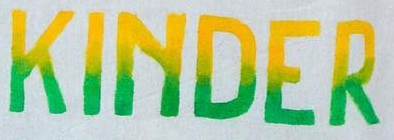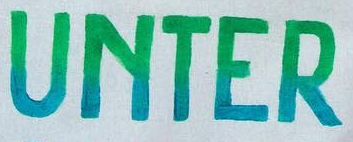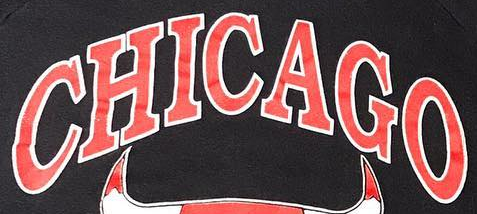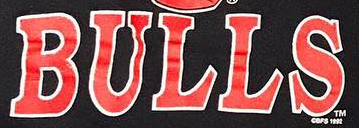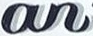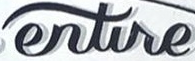What words can you see in these images in sequence, separated by a semicolon? KINDER; UNTER; CHICAGO; BULLS; an; entire 